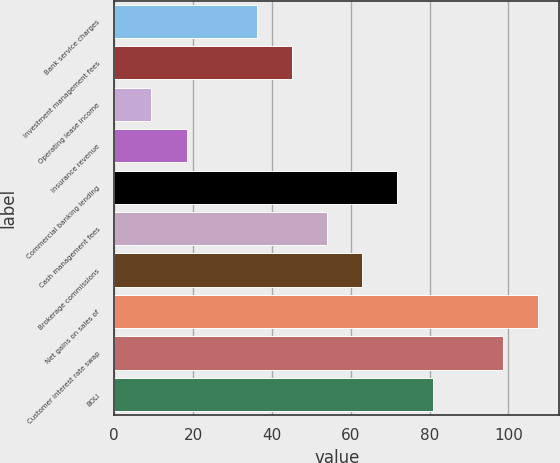<chart> <loc_0><loc_0><loc_500><loc_500><bar_chart><fcel>Bank service charges<fcel>Investment management fees<fcel>Operating lease income<fcel>Insurance revenue<fcel>Commercial banking lending<fcel>Cash management fees<fcel>Brokerage commissions<fcel>Net gains on sales of<fcel>Customer interest rate swap<fcel>BOLI<nl><fcel>36.18<fcel>45.1<fcel>9.42<fcel>18.34<fcel>71.86<fcel>54.02<fcel>62.94<fcel>107.54<fcel>98.62<fcel>80.78<nl></chart> 